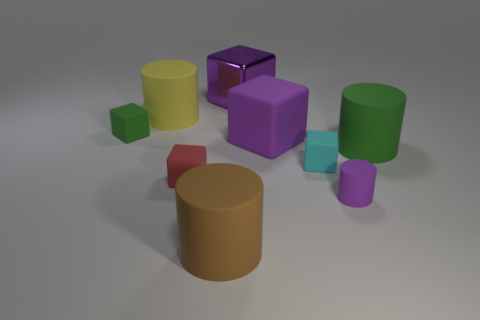What number of large matte cylinders are right of the big brown matte cylinder? There is one large matte cylinder located to the right of the big brown matte cylinder, which has a vivid green color and a smooth surface that reflects the rendered scene's soft lighting. 